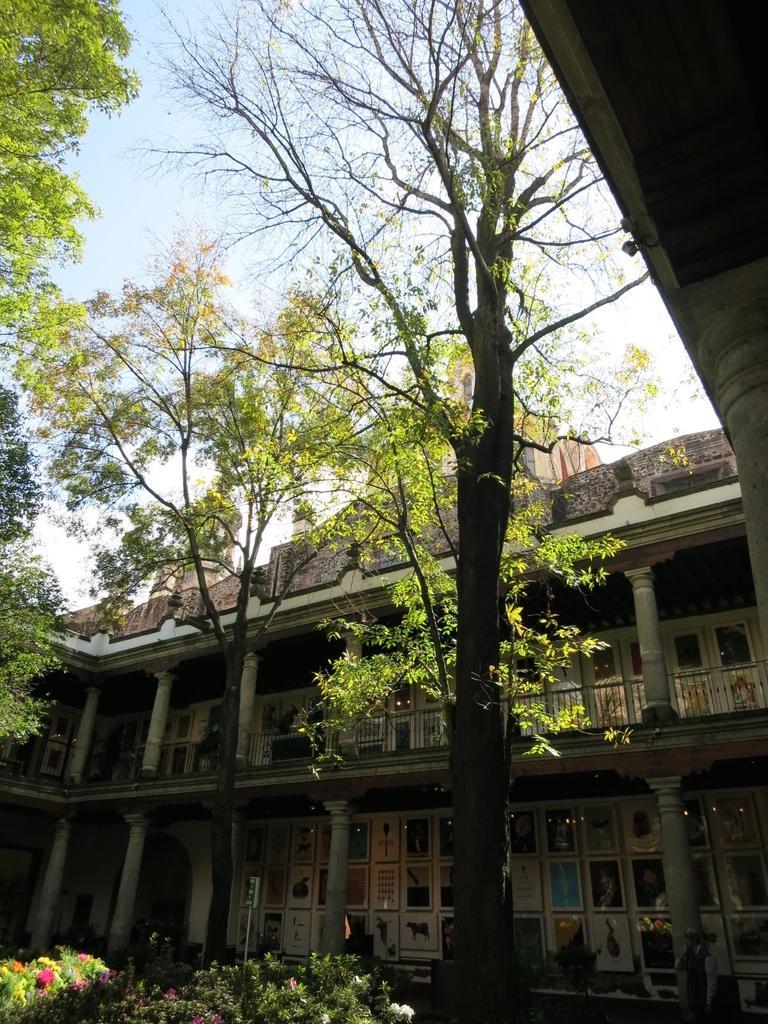Could you give a brief overview of what you see in this image? In this image we can see trees, buildings, plants, flowers, pillars, photo frames and sky. 